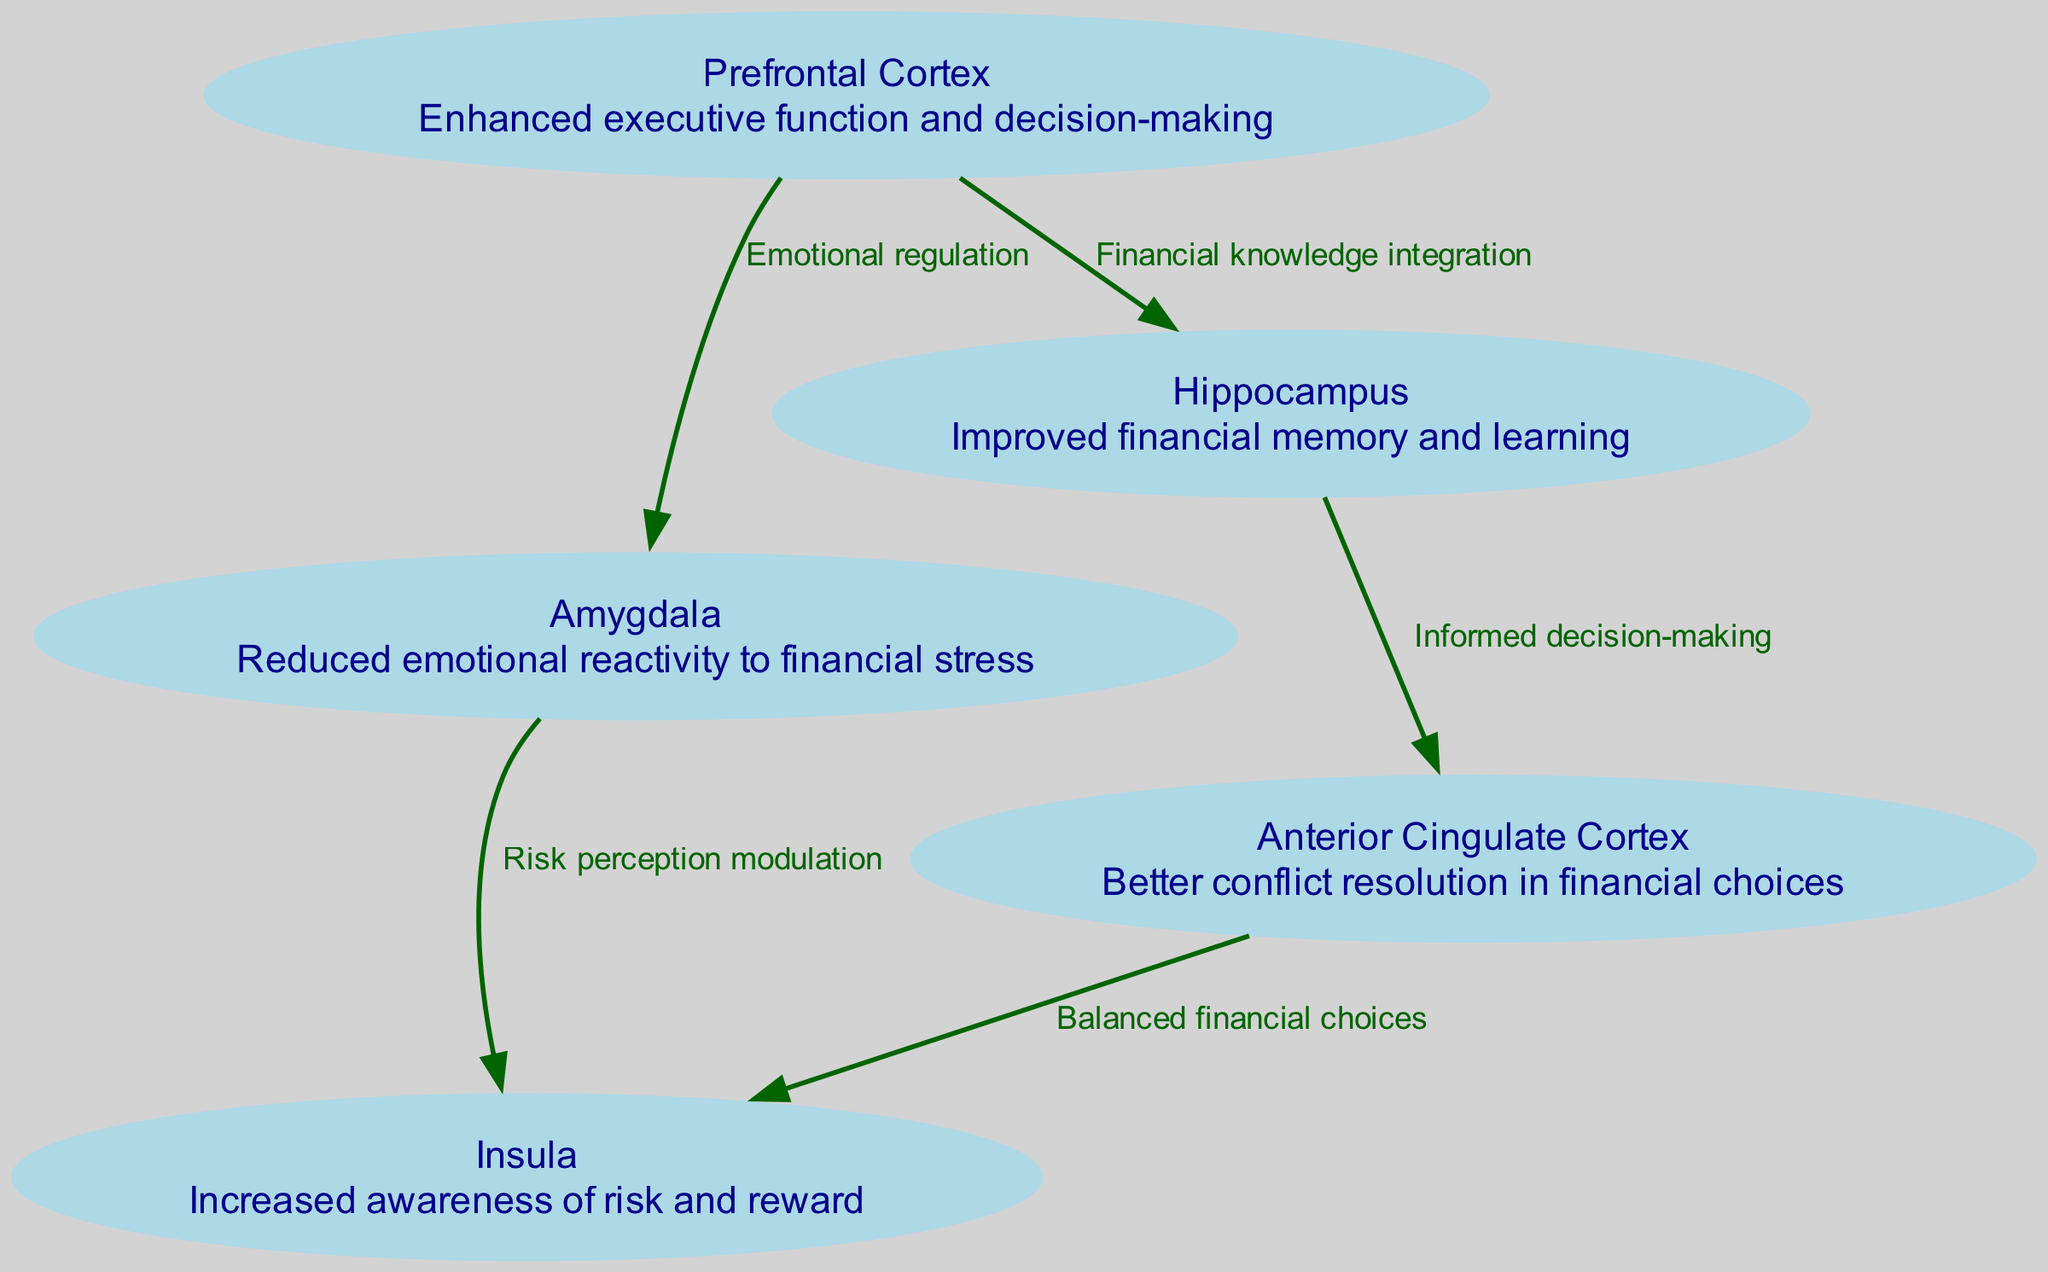What is the description of the Prefrontal Cortex node? The Prefrontal Cortex node has a description that states "Enhanced executive function and decision-making." This is directly read from the node's data in the diagram.
Answer: Enhanced executive function and decision-making How many nodes are there in the diagram? By counting the entries in the "nodes" section of the data, we find there are five individual nodes represented in the diagram.
Answer: 5 What connection does the Anterior Cingulate Cortex have with the Insula? The diagram indicates a directional edge from the Anterior Cingulate Cortex to the Insula, labeled "Balanced financial choices," showing a connection between these two nodes with this specific function.
Answer: Balanced financial choices Which node is connected to the Amygdala for risk perception modulation? According to the diagram, the edge from the Amygdala points to the Insula, specifying that this relationship is characterized by the label "Risk perception modulation." Thus, the Insula is the connected node.
Answer: Insula What psychological role does the Hippocampus improve? The Hippocampus node is described with "Improved financial memory and learning," indicating that its role is focused on enhancing one’s ability to remember and learn about financial matters.
Answer: Improved financial memory and learning How does the Prefrontal Cortex relate to the Amygdala in emotional regulation? The diagram displays a direct edge from the Prefrontal Cortex to the Amygdala labeled "Emotional regulation." This suggests that the Prefrontal Cortex's influence aids in managing emotional responses related to financial decisions.
Answer: Emotional regulation Which two nodes are involved in informed decision-making? The diagram specifies a connection between the Hippocampus and the Anterior Cingulate Cortex labeled "Informed decision-making." This shows that both nodes work together in the context of making knowledgeable financial choices.
Answer: Hippocampus and Anterior Cingulate Cortex What effect does the connection between the Amygdala and Insula facilitate? The directed connection indicates that the relationship is described by "Risk perception modulation," showing that the Amygdala influences how the Insula perceives risk in financial contexts.
Answer: Risk perception modulation Which node is central to financial knowledge integration? The diagram shows that the node Prefrontal Cortex is directly linked to the Hippocampus with the label "Financial knowledge integration," indicating that it plays a key role in processing financial knowledge.
Answer: Prefrontal Cortex 